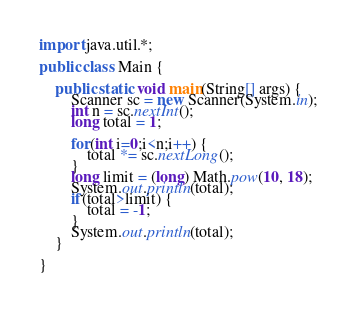<code> <loc_0><loc_0><loc_500><loc_500><_Java_>import java.util.*;

public class Main {

	public static void main(String[] args) {
		Scanner sc = new Scanner(System.in);
		int n = sc.nextInt();
		long total = 1;

		for(int i=0;i<n;i++) {
			total *= sc.nextLong();
		}
		long limit = (long) Math.pow(10, 18);
		System.out.println(total);
		if(total>limit) {
			total = -1;
		}
		System.out.println(total);
	}

}</code> 